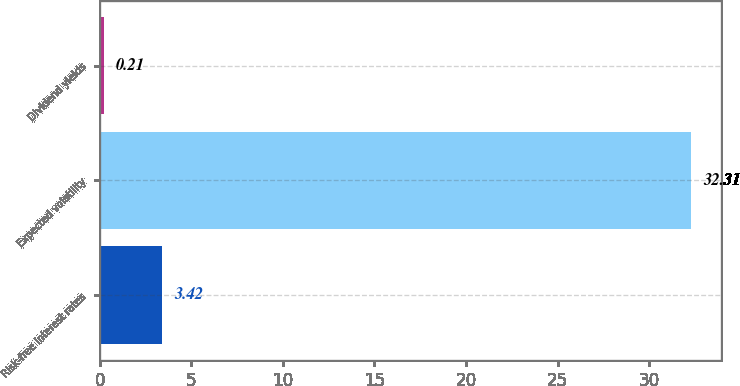Convert chart. <chart><loc_0><loc_0><loc_500><loc_500><bar_chart><fcel>Risk-free interest rates<fcel>Expected volatility<fcel>Dividend yields<nl><fcel>3.42<fcel>32.31<fcel>0.21<nl></chart> 